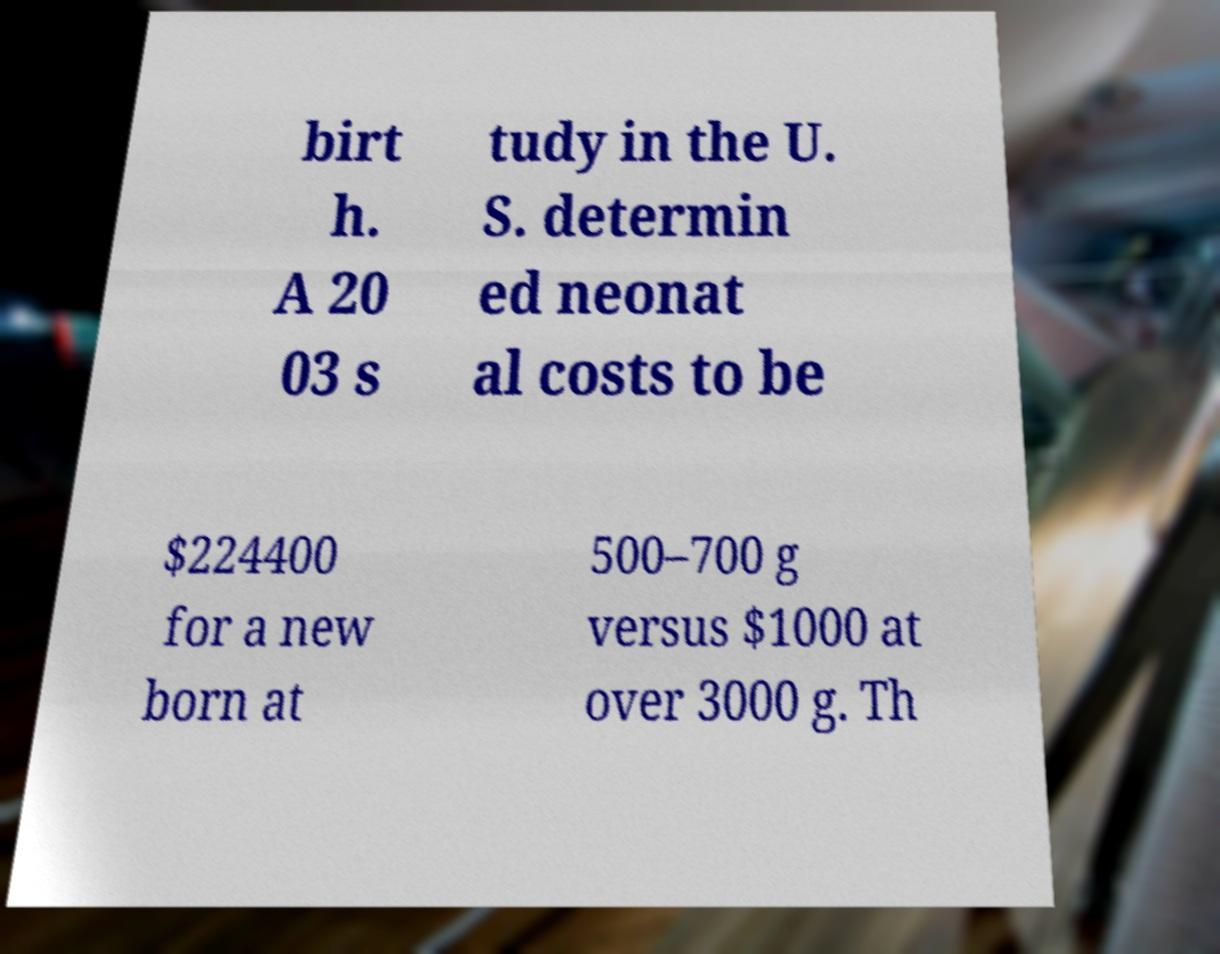Can you read and provide the text displayed in the image?This photo seems to have some interesting text. Can you extract and type it out for me? birt h. A 20 03 s tudy in the U. S. determin ed neonat al costs to be $224400 for a new born at 500–700 g versus $1000 at over 3000 g. Th 